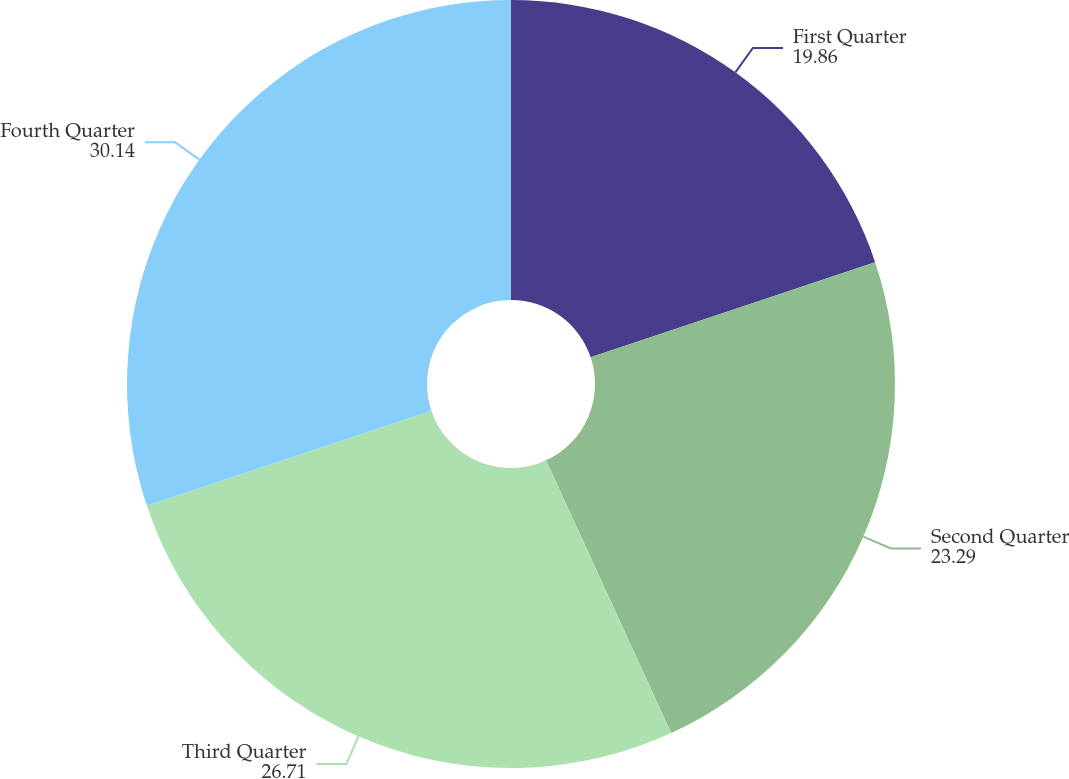Convert chart to OTSL. <chart><loc_0><loc_0><loc_500><loc_500><pie_chart><fcel>First Quarter<fcel>Second Quarter<fcel>Third Quarter<fcel>Fourth Quarter<nl><fcel>19.86%<fcel>23.29%<fcel>26.71%<fcel>30.14%<nl></chart> 